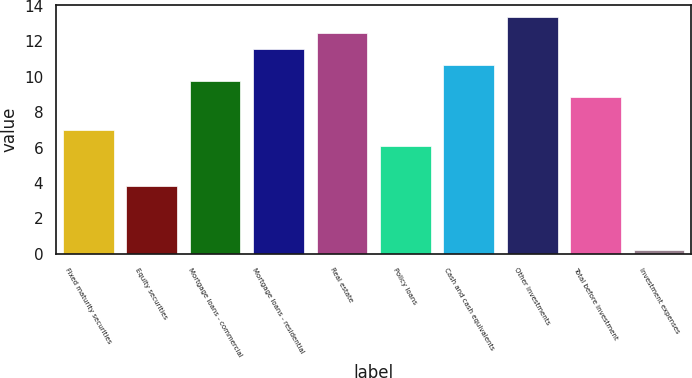Convert chart. <chart><loc_0><loc_0><loc_500><loc_500><bar_chart><fcel>Fixed maturity securities<fcel>Equity securities<fcel>Mortgage loans - commercial<fcel>Mortgage loans - residential<fcel>Real estate<fcel>Policy loans<fcel>Cash and cash equivalents<fcel>Other investments<fcel>Total before investment<fcel>Investment expenses<nl><fcel>7.01<fcel>3.8<fcel>9.74<fcel>11.56<fcel>12.47<fcel>6.1<fcel>10.65<fcel>13.38<fcel>8.83<fcel>0.2<nl></chart> 